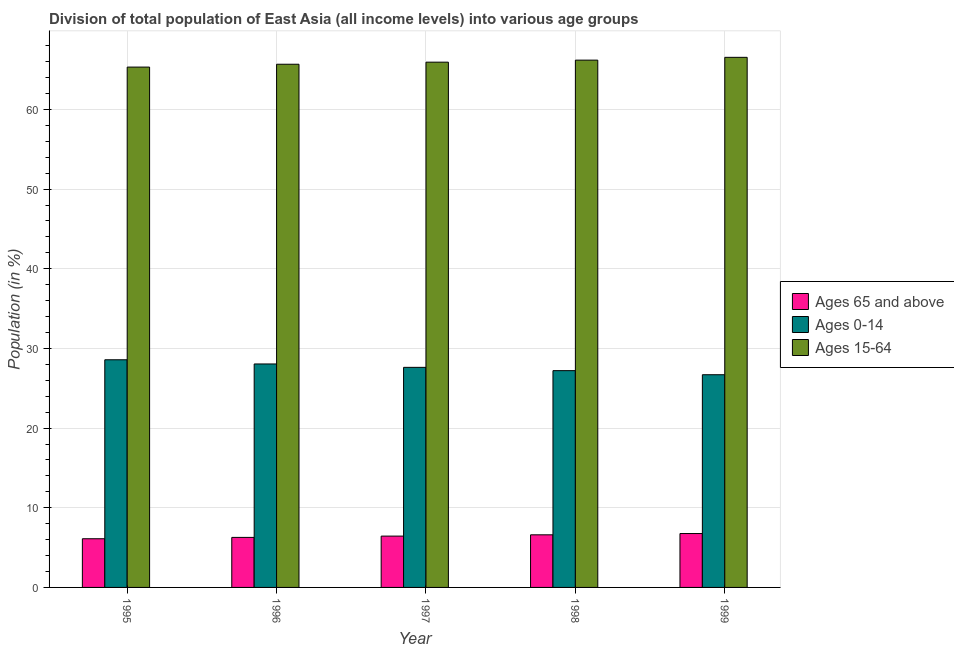How many groups of bars are there?
Keep it short and to the point. 5. Are the number of bars per tick equal to the number of legend labels?
Offer a terse response. Yes. Are the number of bars on each tick of the X-axis equal?
Keep it short and to the point. Yes. How many bars are there on the 1st tick from the right?
Give a very brief answer. 3. What is the percentage of population within the age-group 0-14 in 1996?
Your answer should be compact. 28.05. Across all years, what is the maximum percentage of population within the age-group 0-14?
Offer a terse response. 28.58. Across all years, what is the minimum percentage of population within the age-group 15-64?
Offer a terse response. 65.31. In which year was the percentage of population within the age-group 0-14 maximum?
Keep it short and to the point. 1995. In which year was the percentage of population within the age-group of 65 and above minimum?
Provide a short and direct response. 1995. What is the total percentage of population within the age-group 15-64 in the graph?
Offer a terse response. 329.64. What is the difference between the percentage of population within the age-group 15-64 in 1997 and that in 1998?
Your answer should be very brief. -0.25. What is the difference between the percentage of population within the age-group of 65 and above in 1999 and the percentage of population within the age-group 0-14 in 1997?
Provide a succinct answer. 0.32. What is the average percentage of population within the age-group 0-14 per year?
Give a very brief answer. 27.63. In the year 1995, what is the difference between the percentage of population within the age-group 15-64 and percentage of population within the age-group of 65 and above?
Give a very brief answer. 0. What is the ratio of the percentage of population within the age-group 0-14 in 1996 to that in 1997?
Offer a very short reply. 1.02. Is the percentage of population within the age-group 15-64 in 1996 less than that in 1997?
Ensure brevity in your answer.  Yes. What is the difference between the highest and the second highest percentage of population within the age-group 0-14?
Offer a terse response. 0.53. What is the difference between the highest and the lowest percentage of population within the age-group 15-64?
Your answer should be compact. 1.22. In how many years, is the percentage of population within the age-group of 65 and above greater than the average percentage of population within the age-group of 65 and above taken over all years?
Your response must be concise. 3. What does the 3rd bar from the left in 1997 represents?
Provide a succinct answer. Ages 15-64. What does the 2nd bar from the right in 1995 represents?
Make the answer very short. Ages 0-14. Is it the case that in every year, the sum of the percentage of population within the age-group of 65 and above and percentage of population within the age-group 0-14 is greater than the percentage of population within the age-group 15-64?
Your answer should be compact. No. How many bars are there?
Offer a terse response. 15. How many years are there in the graph?
Make the answer very short. 5. Does the graph contain any zero values?
Ensure brevity in your answer.  No. Does the graph contain grids?
Provide a short and direct response. Yes. Where does the legend appear in the graph?
Your answer should be very brief. Center right. How many legend labels are there?
Offer a very short reply. 3. What is the title of the graph?
Your response must be concise. Division of total population of East Asia (all income levels) into various age groups
. What is the label or title of the Y-axis?
Provide a succinct answer. Population (in %). What is the Population (in %) in Ages 65 and above in 1995?
Your answer should be very brief. 6.11. What is the Population (in %) in Ages 0-14 in 1995?
Give a very brief answer. 28.58. What is the Population (in %) of Ages 15-64 in 1995?
Your response must be concise. 65.31. What is the Population (in %) of Ages 65 and above in 1996?
Your answer should be very brief. 6.28. What is the Population (in %) in Ages 0-14 in 1996?
Ensure brevity in your answer.  28.05. What is the Population (in %) of Ages 15-64 in 1996?
Give a very brief answer. 65.67. What is the Population (in %) in Ages 65 and above in 1997?
Your answer should be compact. 6.44. What is the Population (in %) in Ages 0-14 in 1997?
Provide a succinct answer. 27.62. What is the Population (in %) of Ages 15-64 in 1997?
Provide a succinct answer. 65.93. What is the Population (in %) in Ages 65 and above in 1998?
Provide a short and direct response. 6.6. What is the Population (in %) of Ages 0-14 in 1998?
Provide a short and direct response. 27.21. What is the Population (in %) in Ages 15-64 in 1998?
Give a very brief answer. 66.19. What is the Population (in %) of Ages 65 and above in 1999?
Ensure brevity in your answer.  6.76. What is the Population (in %) in Ages 0-14 in 1999?
Offer a terse response. 26.7. What is the Population (in %) in Ages 15-64 in 1999?
Your answer should be very brief. 66.54. Across all years, what is the maximum Population (in %) in Ages 65 and above?
Make the answer very short. 6.76. Across all years, what is the maximum Population (in %) in Ages 0-14?
Offer a terse response. 28.58. Across all years, what is the maximum Population (in %) in Ages 15-64?
Keep it short and to the point. 66.54. Across all years, what is the minimum Population (in %) in Ages 65 and above?
Give a very brief answer. 6.11. Across all years, what is the minimum Population (in %) of Ages 0-14?
Give a very brief answer. 26.7. Across all years, what is the minimum Population (in %) in Ages 15-64?
Provide a short and direct response. 65.31. What is the total Population (in %) of Ages 65 and above in the graph?
Ensure brevity in your answer.  32.2. What is the total Population (in %) of Ages 0-14 in the graph?
Your answer should be compact. 138.16. What is the total Population (in %) of Ages 15-64 in the graph?
Provide a short and direct response. 329.64. What is the difference between the Population (in %) in Ages 65 and above in 1995 and that in 1996?
Provide a short and direct response. -0.17. What is the difference between the Population (in %) of Ages 0-14 in 1995 and that in 1996?
Ensure brevity in your answer.  0.53. What is the difference between the Population (in %) in Ages 15-64 in 1995 and that in 1996?
Keep it short and to the point. -0.36. What is the difference between the Population (in %) of Ages 65 and above in 1995 and that in 1997?
Offer a terse response. -0.33. What is the difference between the Population (in %) in Ages 0-14 in 1995 and that in 1997?
Your answer should be very brief. 0.95. What is the difference between the Population (in %) of Ages 15-64 in 1995 and that in 1997?
Provide a short and direct response. -0.62. What is the difference between the Population (in %) of Ages 65 and above in 1995 and that in 1998?
Provide a succinct answer. -0.49. What is the difference between the Population (in %) in Ages 0-14 in 1995 and that in 1998?
Offer a very short reply. 1.36. What is the difference between the Population (in %) in Ages 15-64 in 1995 and that in 1998?
Offer a terse response. -0.87. What is the difference between the Population (in %) in Ages 65 and above in 1995 and that in 1999?
Offer a terse response. -0.65. What is the difference between the Population (in %) of Ages 0-14 in 1995 and that in 1999?
Make the answer very short. 1.88. What is the difference between the Population (in %) in Ages 15-64 in 1995 and that in 1999?
Offer a very short reply. -1.22. What is the difference between the Population (in %) in Ages 65 and above in 1996 and that in 1997?
Your response must be concise. -0.16. What is the difference between the Population (in %) of Ages 0-14 in 1996 and that in 1997?
Your response must be concise. 0.43. What is the difference between the Population (in %) of Ages 15-64 in 1996 and that in 1997?
Keep it short and to the point. -0.26. What is the difference between the Population (in %) of Ages 65 and above in 1996 and that in 1998?
Your answer should be compact. -0.32. What is the difference between the Population (in %) of Ages 0-14 in 1996 and that in 1998?
Provide a succinct answer. 0.84. What is the difference between the Population (in %) of Ages 15-64 in 1996 and that in 1998?
Ensure brevity in your answer.  -0.52. What is the difference between the Population (in %) in Ages 65 and above in 1996 and that in 1999?
Provide a short and direct response. -0.48. What is the difference between the Population (in %) in Ages 0-14 in 1996 and that in 1999?
Offer a very short reply. 1.35. What is the difference between the Population (in %) in Ages 15-64 in 1996 and that in 1999?
Your response must be concise. -0.87. What is the difference between the Population (in %) of Ages 65 and above in 1997 and that in 1998?
Ensure brevity in your answer.  -0.16. What is the difference between the Population (in %) of Ages 0-14 in 1997 and that in 1998?
Give a very brief answer. 0.41. What is the difference between the Population (in %) of Ages 15-64 in 1997 and that in 1998?
Offer a very short reply. -0.25. What is the difference between the Population (in %) of Ages 65 and above in 1997 and that in 1999?
Give a very brief answer. -0.32. What is the difference between the Population (in %) of Ages 0-14 in 1997 and that in 1999?
Provide a succinct answer. 0.93. What is the difference between the Population (in %) of Ages 15-64 in 1997 and that in 1999?
Your response must be concise. -0.61. What is the difference between the Population (in %) of Ages 65 and above in 1998 and that in 1999?
Offer a very short reply. -0.16. What is the difference between the Population (in %) in Ages 0-14 in 1998 and that in 1999?
Offer a terse response. 0.51. What is the difference between the Population (in %) in Ages 15-64 in 1998 and that in 1999?
Offer a very short reply. -0.35. What is the difference between the Population (in %) of Ages 65 and above in 1995 and the Population (in %) of Ages 0-14 in 1996?
Your answer should be very brief. -21.94. What is the difference between the Population (in %) in Ages 65 and above in 1995 and the Population (in %) in Ages 15-64 in 1996?
Ensure brevity in your answer.  -59.56. What is the difference between the Population (in %) in Ages 0-14 in 1995 and the Population (in %) in Ages 15-64 in 1996?
Make the answer very short. -37.09. What is the difference between the Population (in %) in Ages 65 and above in 1995 and the Population (in %) in Ages 0-14 in 1997?
Provide a succinct answer. -21.51. What is the difference between the Population (in %) of Ages 65 and above in 1995 and the Population (in %) of Ages 15-64 in 1997?
Give a very brief answer. -59.82. What is the difference between the Population (in %) in Ages 0-14 in 1995 and the Population (in %) in Ages 15-64 in 1997?
Your response must be concise. -37.36. What is the difference between the Population (in %) of Ages 65 and above in 1995 and the Population (in %) of Ages 0-14 in 1998?
Your response must be concise. -21.1. What is the difference between the Population (in %) of Ages 65 and above in 1995 and the Population (in %) of Ages 15-64 in 1998?
Provide a short and direct response. -60.08. What is the difference between the Population (in %) in Ages 0-14 in 1995 and the Population (in %) in Ages 15-64 in 1998?
Give a very brief answer. -37.61. What is the difference between the Population (in %) in Ages 65 and above in 1995 and the Population (in %) in Ages 0-14 in 1999?
Your answer should be compact. -20.59. What is the difference between the Population (in %) of Ages 65 and above in 1995 and the Population (in %) of Ages 15-64 in 1999?
Keep it short and to the point. -60.43. What is the difference between the Population (in %) in Ages 0-14 in 1995 and the Population (in %) in Ages 15-64 in 1999?
Your response must be concise. -37.96. What is the difference between the Population (in %) in Ages 65 and above in 1996 and the Population (in %) in Ages 0-14 in 1997?
Give a very brief answer. -21.34. What is the difference between the Population (in %) in Ages 65 and above in 1996 and the Population (in %) in Ages 15-64 in 1997?
Offer a very short reply. -59.65. What is the difference between the Population (in %) in Ages 0-14 in 1996 and the Population (in %) in Ages 15-64 in 1997?
Your response must be concise. -37.88. What is the difference between the Population (in %) in Ages 65 and above in 1996 and the Population (in %) in Ages 0-14 in 1998?
Make the answer very short. -20.93. What is the difference between the Population (in %) of Ages 65 and above in 1996 and the Population (in %) of Ages 15-64 in 1998?
Keep it short and to the point. -59.91. What is the difference between the Population (in %) in Ages 0-14 in 1996 and the Population (in %) in Ages 15-64 in 1998?
Give a very brief answer. -38.14. What is the difference between the Population (in %) of Ages 65 and above in 1996 and the Population (in %) of Ages 0-14 in 1999?
Ensure brevity in your answer.  -20.42. What is the difference between the Population (in %) of Ages 65 and above in 1996 and the Population (in %) of Ages 15-64 in 1999?
Your answer should be compact. -60.26. What is the difference between the Population (in %) of Ages 0-14 in 1996 and the Population (in %) of Ages 15-64 in 1999?
Your response must be concise. -38.49. What is the difference between the Population (in %) in Ages 65 and above in 1997 and the Population (in %) in Ages 0-14 in 1998?
Your answer should be compact. -20.77. What is the difference between the Population (in %) of Ages 65 and above in 1997 and the Population (in %) of Ages 15-64 in 1998?
Your answer should be very brief. -59.74. What is the difference between the Population (in %) of Ages 0-14 in 1997 and the Population (in %) of Ages 15-64 in 1998?
Make the answer very short. -38.56. What is the difference between the Population (in %) in Ages 65 and above in 1997 and the Population (in %) in Ages 0-14 in 1999?
Provide a short and direct response. -20.25. What is the difference between the Population (in %) in Ages 65 and above in 1997 and the Population (in %) in Ages 15-64 in 1999?
Provide a short and direct response. -60.1. What is the difference between the Population (in %) in Ages 0-14 in 1997 and the Population (in %) in Ages 15-64 in 1999?
Your answer should be compact. -38.91. What is the difference between the Population (in %) of Ages 65 and above in 1998 and the Population (in %) of Ages 0-14 in 1999?
Provide a succinct answer. -20.09. What is the difference between the Population (in %) in Ages 65 and above in 1998 and the Population (in %) in Ages 15-64 in 1999?
Your answer should be very brief. -59.94. What is the difference between the Population (in %) in Ages 0-14 in 1998 and the Population (in %) in Ages 15-64 in 1999?
Give a very brief answer. -39.33. What is the average Population (in %) of Ages 65 and above per year?
Provide a short and direct response. 6.44. What is the average Population (in %) of Ages 0-14 per year?
Your answer should be compact. 27.63. What is the average Population (in %) of Ages 15-64 per year?
Offer a very short reply. 65.93. In the year 1995, what is the difference between the Population (in %) of Ages 65 and above and Population (in %) of Ages 0-14?
Your answer should be very brief. -22.46. In the year 1995, what is the difference between the Population (in %) of Ages 65 and above and Population (in %) of Ages 15-64?
Provide a short and direct response. -59.2. In the year 1995, what is the difference between the Population (in %) of Ages 0-14 and Population (in %) of Ages 15-64?
Keep it short and to the point. -36.74. In the year 1996, what is the difference between the Population (in %) in Ages 65 and above and Population (in %) in Ages 0-14?
Offer a very short reply. -21.77. In the year 1996, what is the difference between the Population (in %) of Ages 65 and above and Population (in %) of Ages 15-64?
Offer a very short reply. -59.39. In the year 1996, what is the difference between the Population (in %) of Ages 0-14 and Population (in %) of Ages 15-64?
Your response must be concise. -37.62. In the year 1997, what is the difference between the Population (in %) of Ages 65 and above and Population (in %) of Ages 0-14?
Keep it short and to the point. -21.18. In the year 1997, what is the difference between the Population (in %) in Ages 65 and above and Population (in %) in Ages 15-64?
Make the answer very short. -59.49. In the year 1997, what is the difference between the Population (in %) in Ages 0-14 and Population (in %) in Ages 15-64?
Your answer should be compact. -38.31. In the year 1998, what is the difference between the Population (in %) in Ages 65 and above and Population (in %) in Ages 0-14?
Offer a terse response. -20.61. In the year 1998, what is the difference between the Population (in %) of Ages 65 and above and Population (in %) of Ages 15-64?
Make the answer very short. -59.58. In the year 1998, what is the difference between the Population (in %) of Ages 0-14 and Population (in %) of Ages 15-64?
Give a very brief answer. -38.98. In the year 1999, what is the difference between the Population (in %) in Ages 65 and above and Population (in %) in Ages 0-14?
Make the answer very short. -19.93. In the year 1999, what is the difference between the Population (in %) of Ages 65 and above and Population (in %) of Ages 15-64?
Give a very brief answer. -59.77. In the year 1999, what is the difference between the Population (in %) in Ages 0-14 and Population (in %) in Ages 15-64?
Provide a short and direct response. -39.84. What is the ratio of the Population (in %) in Ages 65 and above in 1995 to that in 1996?
Provide a short and direct response. 0.97. What is the ratio of the Population (in %) in Ages 0-14 in 1995 to that in 1996?
Your response must be concise. 1.02. What is the ratio of the Population (in %) of Ages 65 and above in 1995 to that in 1997?
Offer a terse response. 0.95. What is the ratio of the Population (in %) of Ages 0-14 in 1995 to that in 1997?
Offer a terse response. 1.03. What is the ratio of the Population (in %) in Ages 15-64 in 1995 to that in 1997?
Provide a succinct answer. 0.99. What is the ratio of the Population (in %) of Ages 65 and above in 1995 to that in 1998?
Ensure brevity in your answer.  0.93. What is the ratio of the Population (in %) of Ages 0-14 in 1995 to that in 1998?
Offer a very short reply. 1.05. What is the ratio of the Population (in %) in Ages 65 and above in 1995 to that in 1999?
Make the answer very short. 0.9. What is the ratio of the Population (in %) of Ages 0-14 in 1995 to that in 1999?
Offer a terse response. 1.07. What is the ratio of the Population (in %) of Ages 15-64 in 1995 to that in 1999?
Offer a terse response. 0.98. What is the ratio of the Population (in %) in Ages 65 and above in 1996 to that in 1997?
Keep it short and to the point. 0.97. What is the ratio of the Population (in %) of Ages 0-14 in 1996 to that in 1997?
Your response must be concise. 1.02. What is the ratio of the Population (in %) in Ages 15-64 in 1996 to that in 1997?
Offer a very short reply. 1. What is the ratio of the Population (in %) of Ages 65 and above in 1996 to that in 1998?
Make the answer very short. 0.95. What is the ratio of the Population (in %) in Ages 0-14 in 1996 to that in 1998?
Keep it short and to the point. 1.03. What is the ratio of the Population (in %) of Ages 65 and above in 1996 to that in 1999?
Your response must be concise. 0.93. What is the ratio of the Population (in %) in Ages 0-14 in 1996 to that in 1999?
Your response must be concise. 1.05. What is the ratio of the Population (in %) in Ages 15-64 in 1996 to that in 1999?
Your response must be concise. 0.99. What is the ratio of the Population (in %) in Ages 65 and above in 1997 to that in 1998?
Your answer should be very brief. 0.98. What is the ratio of the Population (in %) of Ages 0-14 in 1997 to that in 1998?
Offer a very short reply. 1.02. What is the ratio of the Population (in %) in Ages 65 and above in 1997 to that in 1999?
Your answer should be very brief. 0.95. What is the ratio of the Population (in %) of Ages 0-14 in 1997 to that in 1999?
Make the answer very short. 1.03. What is the ratio of the Population (in %) of Ages 15-64 in 1997 to that in 1999?
Offer a terse response. 0.99. What is the ratio of the Population (in %) of Ages 65 and above in 1998 to that in 1999?
Your answer should be compact. 0.98. What is the ratio of the Population (in %) of Ages 0-14 in 1998 to that in 1999?
Ensure brevity in your answer.  1.02. What is the ratio of the Population (in %) of Ages 15-64 in 1998 to that in 1999?
Your answer should be compact. 0.99. What is the difference between the highest and the second highest Population (in %) in Ages 65 and above?
Provide a short and direct response. 0.16. What is the difference between the highest and the second highest Population (in %) in Ages 0-14?
Your answer should be compact. 0.53. What is the difference between the highest and the second highest Population (in %) of Ages 15-64?
Your response must be concise. 0.35. What is the difference between the highest and the lowest Population (in %) in Ages 65 and above?
Provide a short and direct response. 0.65. What is the difference between the highest and the lowest Population (in %) in Ages 0-14?
Give a very brief answer. 1.88. What is the difference between the highest and the lowest Population (in %) in Ages 15-64?
Keep it short and to the point. 1.22. 